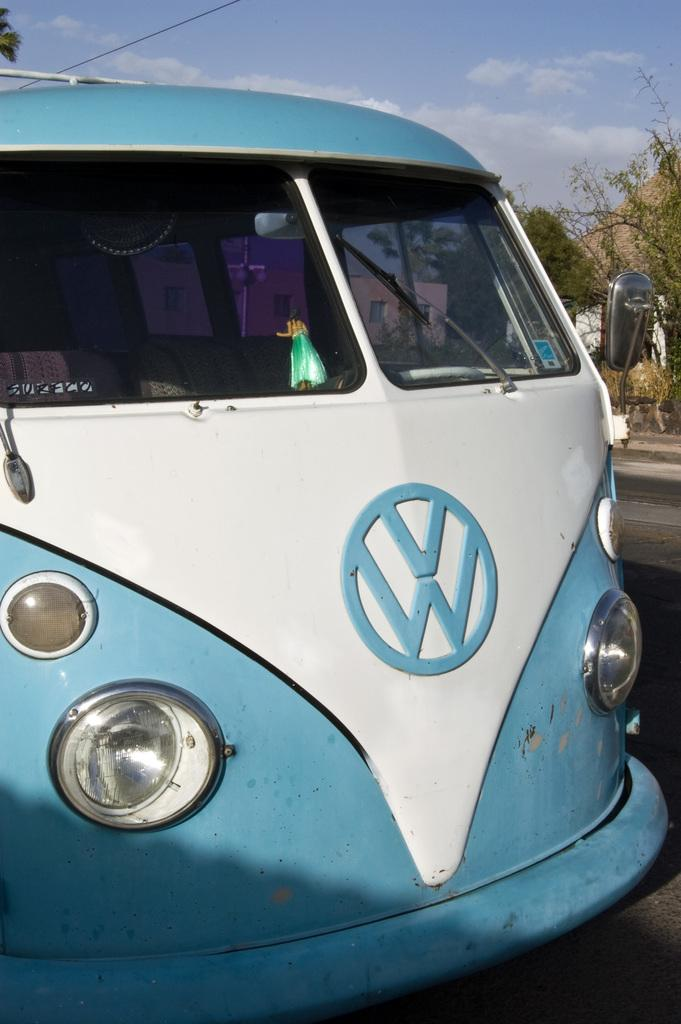<image>
Relay a brief, clear account of the picture shown. A blue and white vehicle parked on the road 